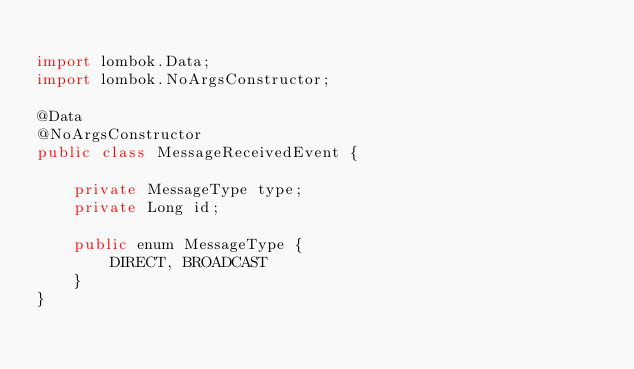<code> <loc_0><loc_0><loc_500><loc_500><_Java_>
import lombok.Data;
import lombok.NoArgsConstructor;

@Data
@NoArgsConstructor
public class MessageReceivedEvent {

    private MessageType type;
    private Long id;

    public enum MessageType {
        DIRECT, BROADCAST
    }
}
</code> 